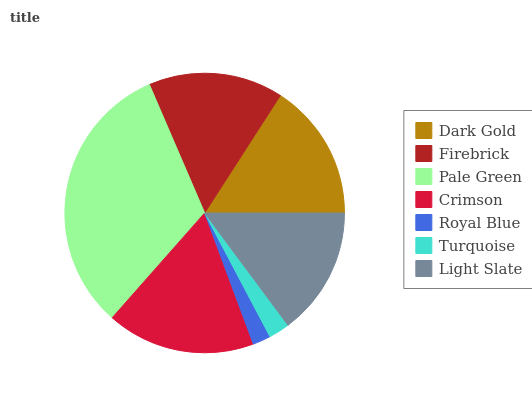Is Royal Blue the minimum?
Answer yes or no. Yes. Is Pale Green the maximum?
Answer yes or no. Yes. Is Firebrick the minimum?
Answer yes or no. No. Is Firebrick the maximum?
Answer yes or no. No. Is Dark Gold greater than Firebrick?
Answer yes or no. Yes. Is Firebrick less than Dark Gold?
Answer yes or no. Yes. Is Firebrick greater than Dark Gold?
Answer yes or no. No. Is Dark Gold less than Firebrick?
Answer yes or no. No. Is Firebrick the high median?
Answer yes or no. Yes. Is Firebrick the low median?
Answer yes or no. Yes. Is Crimson the high median?
Answer yes or no. No. Is Dark Gold the low median?
Answer yes or no. No. 